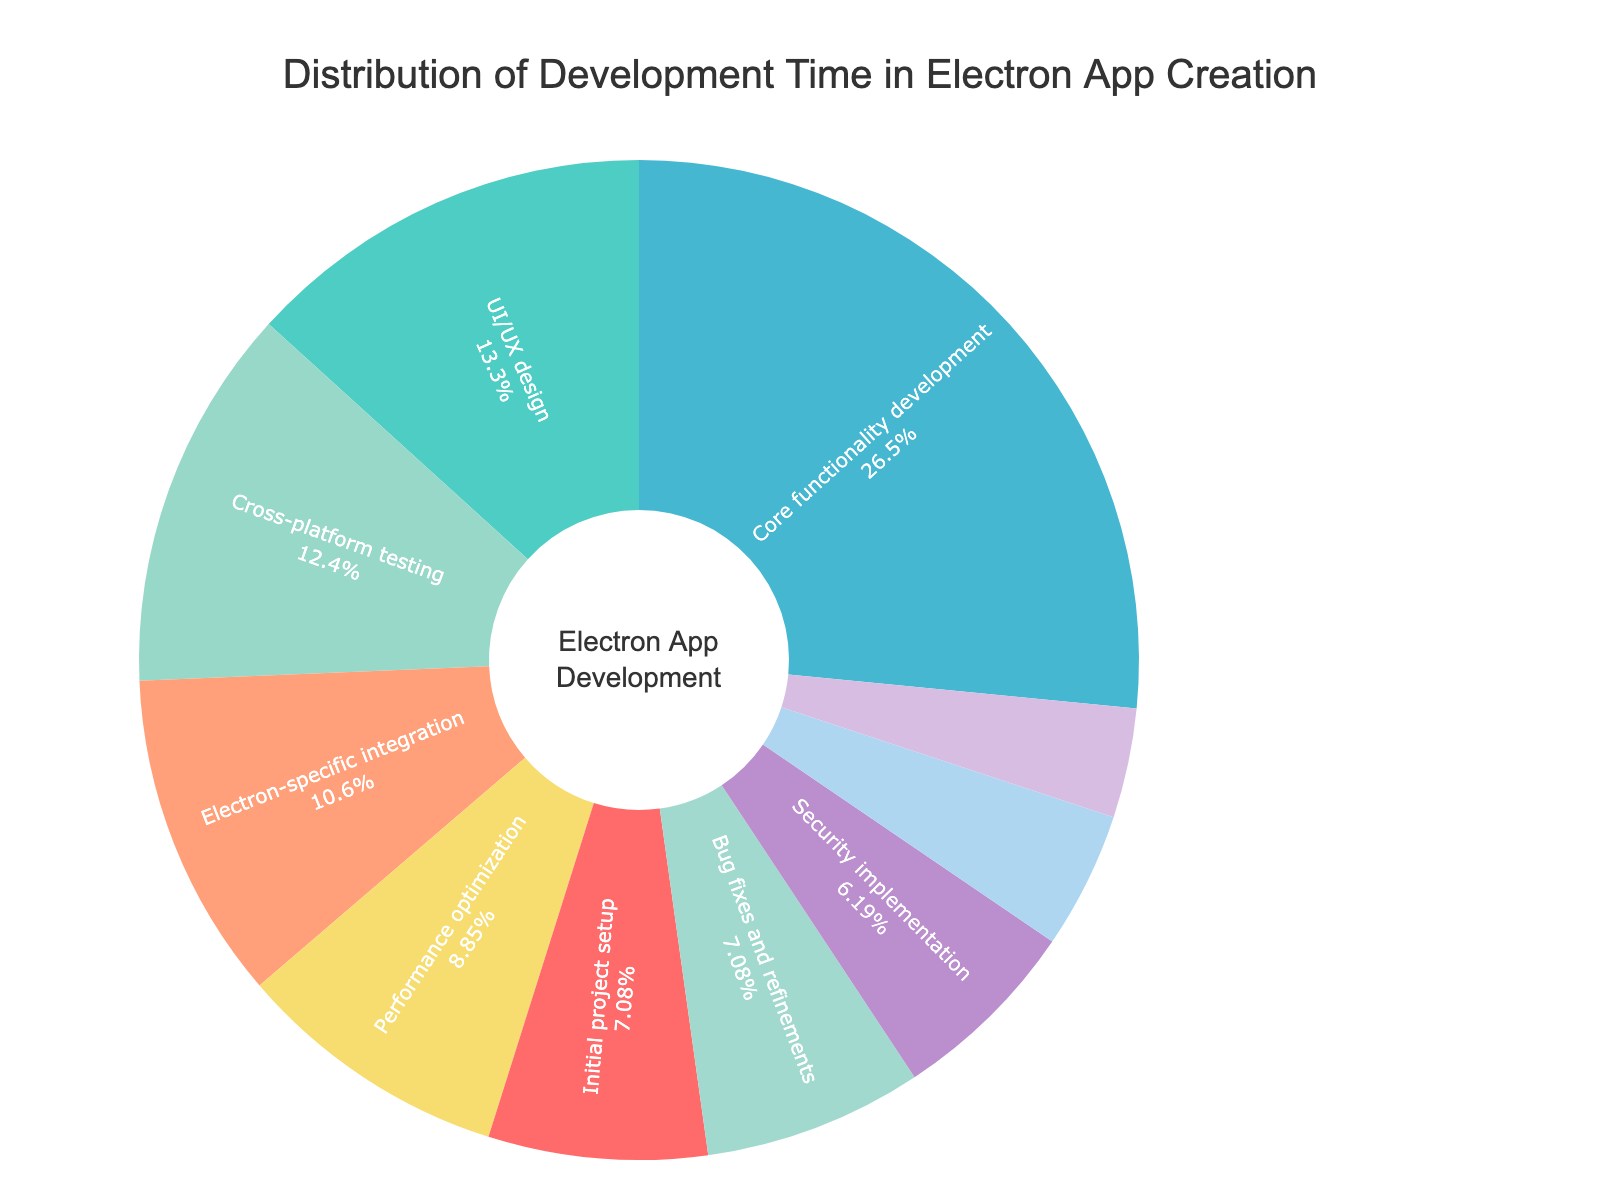What's the most time-consuming stage in the development process? By looking at the pie chart, identify the segment with the largest percentage. The largest segment represents "Core functionality development" which takes up 30% of the total time.
Answer: Core functionality development How much total time is spent on testing and performance optimization? To find the total time spent on testing and performance optimization, combine the percentages for "Cross-platform testing" (14%) and "Performance optimization" (10%). The sum is 24%.
Answer: 24% Which stage takes more time, Security implementation or Documentation and user guides? Compare the percentages given for "Security implementation" (7%) and "Documentation and user guides" (4%). Since 7% is greater than 4%, "Security implementation" takes more time.
Answer: Security implementation What percentage of time is spent on initial project setup and bug fixes combined? Add the percentages for "Initial project setup" (8%) and "Bug fixes and refinements" (8%). The combined time spent is 8% + 8% = 16%.
Answer: 16% Which stages take equal amounts of time and what are their percentages? Identify the stages with the same percentage. Both "Initial project setup" and "Bug fixes and refinements" each take 8% of the time.
Answer: Initial project setup and Bug fixes and refinements, 8% each Between UI/UX design and Final packaging and distribution, which one takes less time? Compare "UI/UX design" which takes 15% and "Final packaging and distribution" which takes 5%. Since 5% is less than 15%, "Final packaging and distribution" takes less time.
Answer: Final packaging and distribution If the time for Core functionality development was reduced by 10%, how much time would this stage take then? First, calculate 10% of 30% which is 3%. Then, subtract 3% from 30% to find the reduced time, which gives 27%.
Answer: 27% What's the total percentage of the stages taking single-digit time? Sum up the percentages of stages with single-digit values: Initial project setup (8%), Security implementation (7%), Documentation and user guides (4%), Final packaging and distribution (5%), and Bug fixes and refinements (8%). The total is 8 + 7 + 4 + 5 + 8 = 32%.
Answer: 32% How does the time for Electron-specific integration compare to Performance optimization? Electron-specific integration takes 12% while Performance optimization takes 10%. Since 12% is greater than 10%, Electron-specific integration takes more time.
Answer: Electron-specific integration takes more time What is the difference in time between the most and least time-consuming stages? The most time-consuming stage is "Core functionality development" with 30%. The least time-consuming stage is "Documentation and user guides" with 4%. The difference is 30% - 4% = 26%.
Answer: 26% 